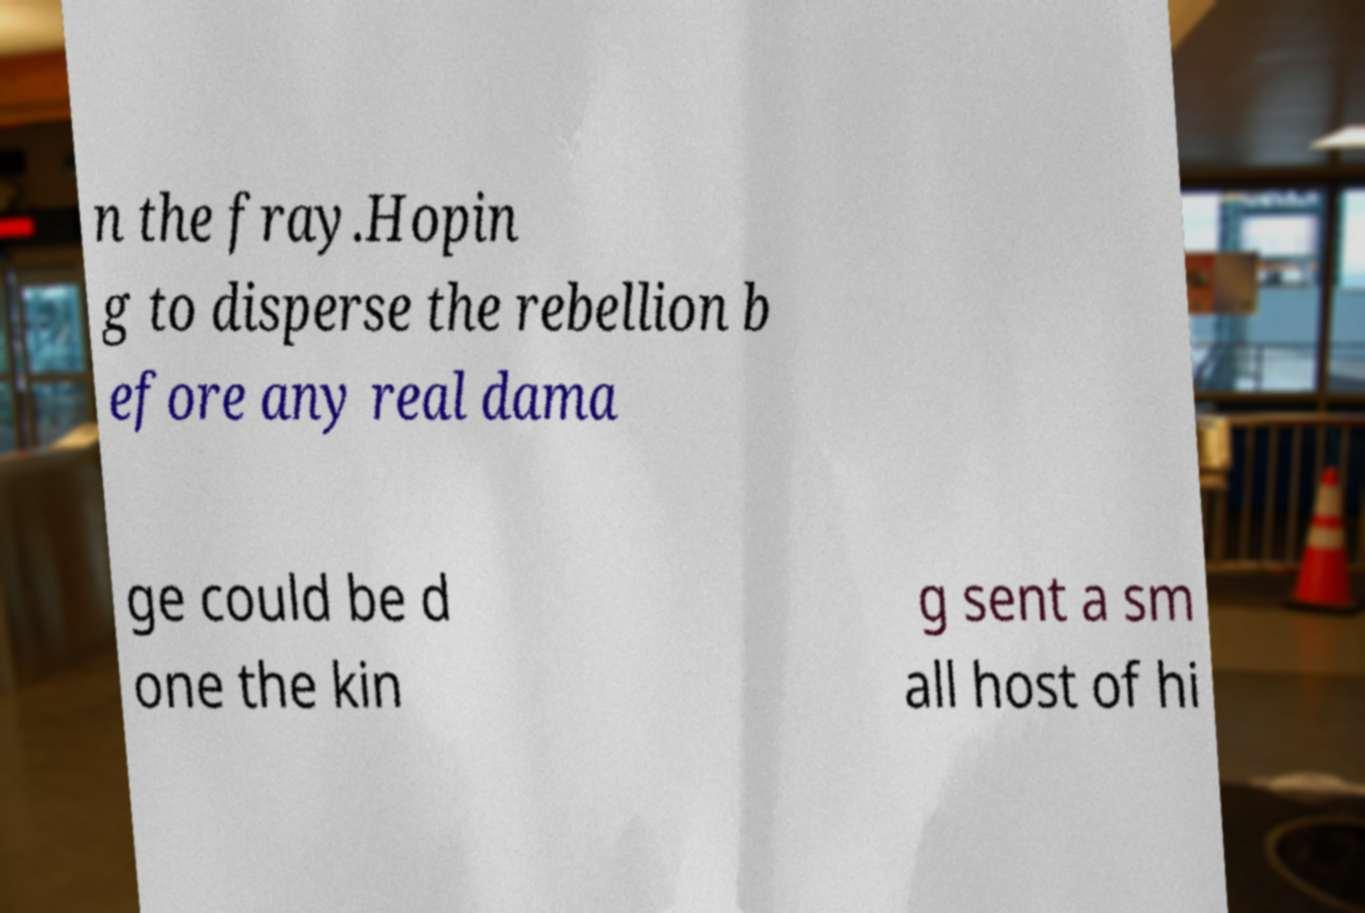Please read and relay the text visible in this image. What does it say? n the fray.Hopin g to disperse the rebellion b efore any real dama ge could be d one the kin g sent a sm all host of hi 